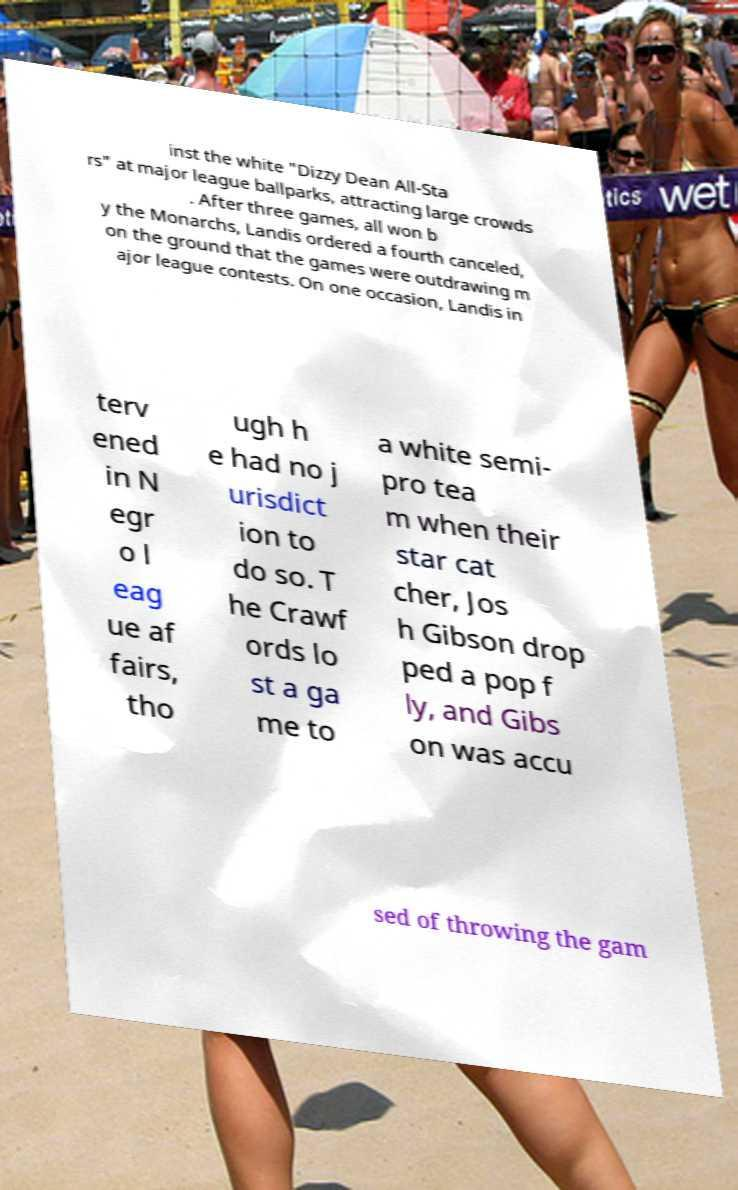There's text embedded in this image that I need extracted. Can you transcribe it verbatim? inst the white "Dizzy Dean All-Sta rs" at major league ballparks, attracting large crowds . After three games, all won b y the Monarchs, Landis ordered a fourth canceled, on the ground that the games were outdrawing m ajor league contests. On one occasion, Landis in terv ened in N egr o l eag ue af fairs, tho ugh h e had no j urisdict ion to do so. T he Crawf ords lo st a ga me to a white semi- pro tea m when their star cat cher, Jos h Gibson drop ped a pop f ly, and Gibs on was accu sed of throwing the gam 